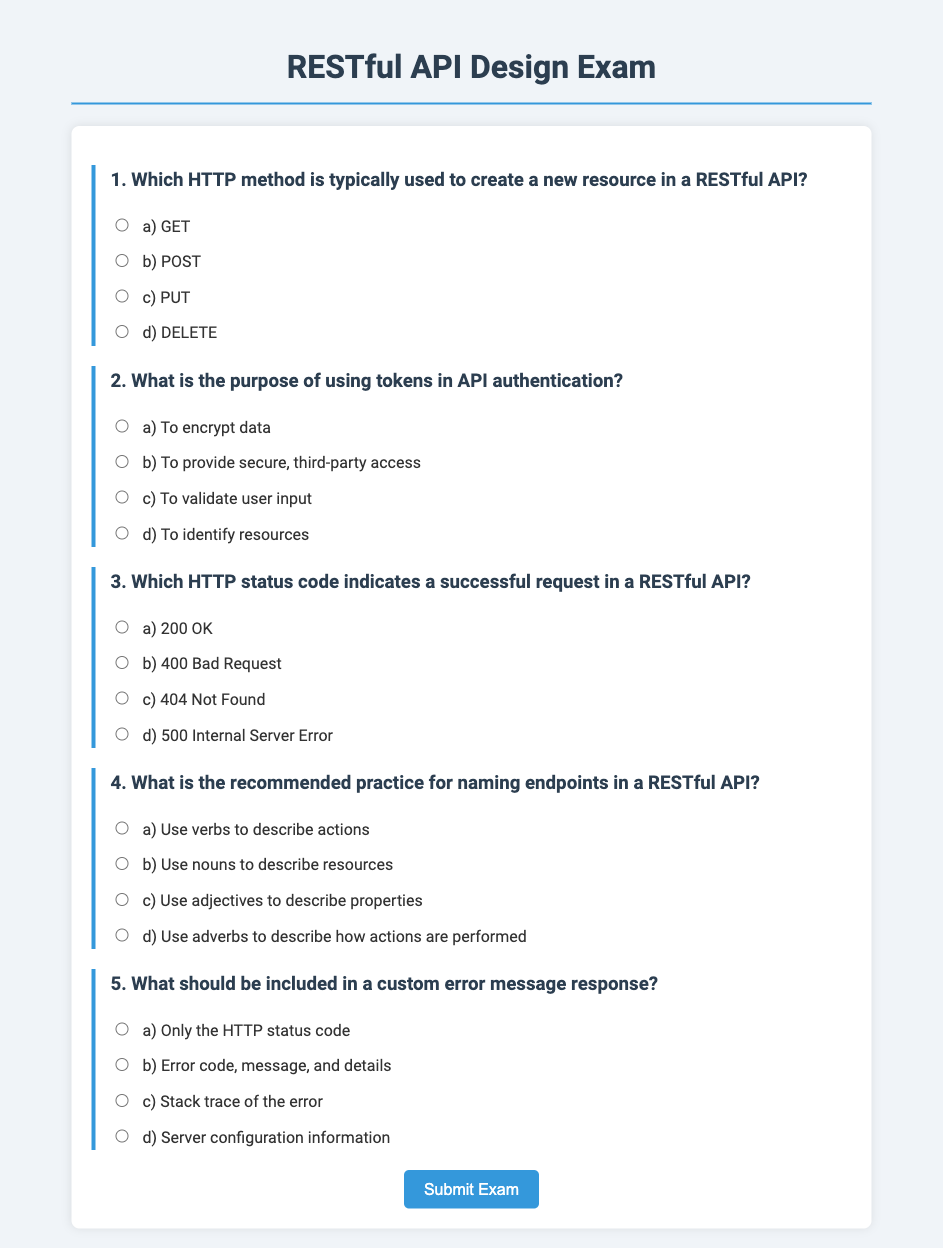Which HTTP method is typically used to create a new resource in a RESTful API? The document explicitly states that the method used to create a new resource is indicated in question 1.
Answer: POST What is the purpose of using tokens in API authentication? Question 2 in the document asks about the role of tokens in API authentication.
Answer: To provide secure, third-party access Which HTTP status code indicates a successful request in a RESTful API? The document identifies the correct HTTP status code for a successful request in question 3.
Answer: 200 OK What is the recommended practice for naming endpoints in a RESTful API? Question 4 refers to the naming conventions recommended for API endpoints in the document.
Answer: Use nouns to describe resources What should be included in a custom error message response? The document points out the components that should be part of a custom error message in question 5.
Answer: Error code, message, and details 